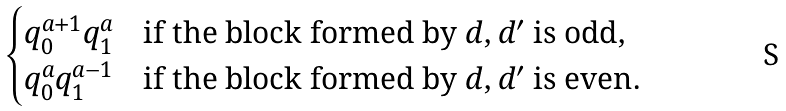Convert formula to latex. <formula><loc_0><loc_0><loc_500><loc_500>\begin{cases} q _ { 0 } ^ { a + 1 } q _ { 1 } ^ { a } & \text {if the block formed by } d , d ^ { \prime } \text { is odd} , \\ q _ { 0 } ^ { a } q _ { 1 } ^ { a - 1 } & \text {if the block formed by } d , d ^ { \prime } \text { is even} . \end{cases}</formula> 